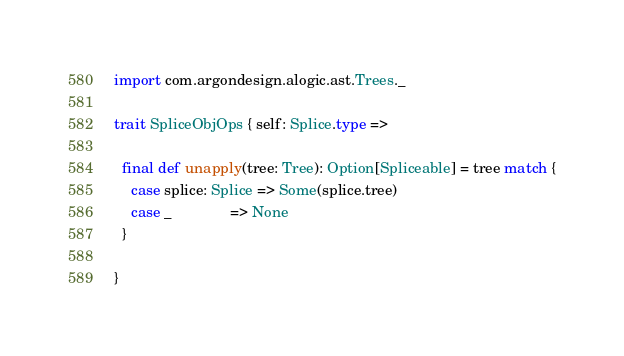<code> <loc_0><loc_0><loc_500><loc_500><_Scala_>import com.argondesign.alogic.ast.Trees._

trait SpliceObjOps { self: Splice.type =>

  final def unapply(tree: Tree): Option[Spliceable] = tree match {
    case splice: Splice => Some(splice.tree)
    case _              => None
  }

}
</code> 